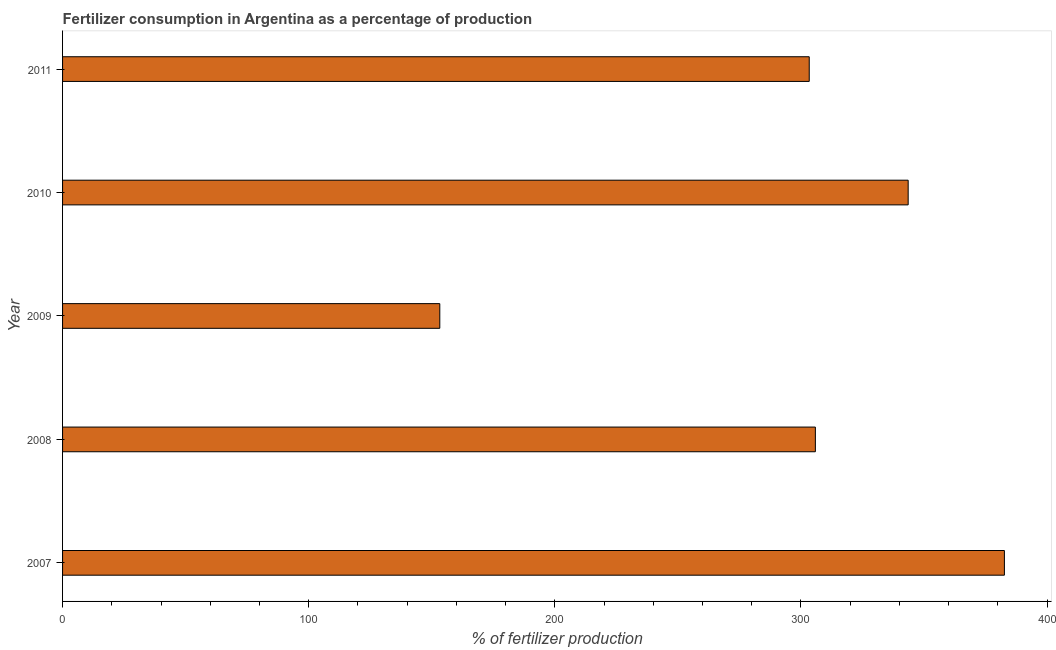Does the graph contain any zero values?
Provide a succinct answer. No. What is the title of the graph?
Provide a succinct answer. Fertilizer consumption in Argentina as a percentage of production. What is the label or title of the X-axis?
Offer a terse response. % of fertilizer production. What is the label or title of the Y-axis?
Offer a very short reply. Year. What is the amount of fertilizer consumption in 2007?
Offer a very short reply. 382.69. Across all years, what is the maximum amount of fertilizer consumption?
Make the answer very short. 382.69. Across all years, what is the minimum amount of fertilizer consumption?
Your answer should be compact. 153.28. What is the sum of the amount of fertilizer consumption?
Your answer should be compact. 1488.83. What is the difference between the amount of fertilizer consumption in 2007 and 2011?
Keep it short and to the point. 79.3. What is the average amount of fertilizer consumption per year?
Your response must be concise. 297.76. What is the median amount of fertilizer consumption?
Your response must be concise. 305.88. Do a majority of the years between 2009 and 2007 (inclusive) have amount of fertilizer consumption greater than 60 %?
Keep it short and to the point. Yes. What is the ratio of the amount of fertilizer consumption in 2009 to that in 2011?
Provide a succinct answer. 0.51. What is the difference between the highest and the second highest amount of fertilizer consumption?
Make the answer very short. 39.1. What is the difference between the highest and the lowest amount of fertilizer consumption?
Provide a succinct answer. 229.41. How many years are there in the graph?
Make the answer very short. 5. What is the difference between two consecutive major ticks on the X-axis?
Offer a terse response. 100. What is the % of fertilizer production of 2007?
Your answer should be compact. 382.69. What is the % of fertilizer production in 2008?
Keep it short and to the point. 305.88. What is the % of fertilizer production of 2009?
Your answer should be compact. 153.28. What is the % of fertilizer production in 2010?
Offer a very short reply. 343.59. What is the % of fertilizer production of 2011?
Your response must be concise. 303.39. What is the difference between the % of fertilizer production in 2007 and 2008?
Offer a very short reply. 76.81. What is the difference between the % of fertilizer production in 2007 and 2009?
Offer a very short reply. 229.41. What is the difference between the % of fertilizer production in 2007 and 2010?
Offer a terse response. 39.1. What is the difference between the % of fertilizer production in 2007 and 2011?
Ensure brevity in your answer.  79.3. What is the difference between the % of fertilizer production in 2008 and 2009?
Give a very brief answer. 152.6. What is the difference between the % of fertilizer production in 2008 and 2010?
Your answer should be compact. -37.71. What is the difference between the % of fertilizer production in 2008 and 2011?
Your answer should be very brief. 2.49. What is the difference between the % of fertilizer production in 2009 and 2010?
Your answer should be compact. -190.31. What is the difference between the % of fertilizer production in 2009 and 2011?
Keep it short and to the point. -150.11. What is the difference between the % of fertilizer production in 2010 and 2011?
Provide a short and direct response. 40.2. What is the ratio of the % of fertilizer production in 2007 to that in 2008?
Your answer should be compact. 1.25. What is the ratio of the % of fertilizer production in 2007 to that in 2009?
Your answer should be compact. 2.5. What is the ratio of the % of fertilizer production in 2007 to that in 2010?
Your answer should be very brief. 1.11. What is the ratio of the % of fertilizer production in 2007 to that in 2011?
Your response must be concise. 1.26. What is the ratio of the % of fertilizer production in 2008 to that in 2009?
Offer a terse response. 2. What is the ratio of the % of fertilizer production in 2008 to that in 2010?
Provide a succinct answer. 0.89. What is the ratio of the % of fertilizer production in 2008 to that in 2011?
Keep it short and to the point. 1.01. What is the ratio of the % of fertilizer production in 2009 to that in 2010?
Offer a very short reply. 0.45. What is the ratio of the % of fertilizer production in 2009 to that in 2011?
Give a very brief answer. 0.51. What is the ratio of the % of fertilizer production in 2010 to that in 2011?
Make the answer very short. 1.13. 